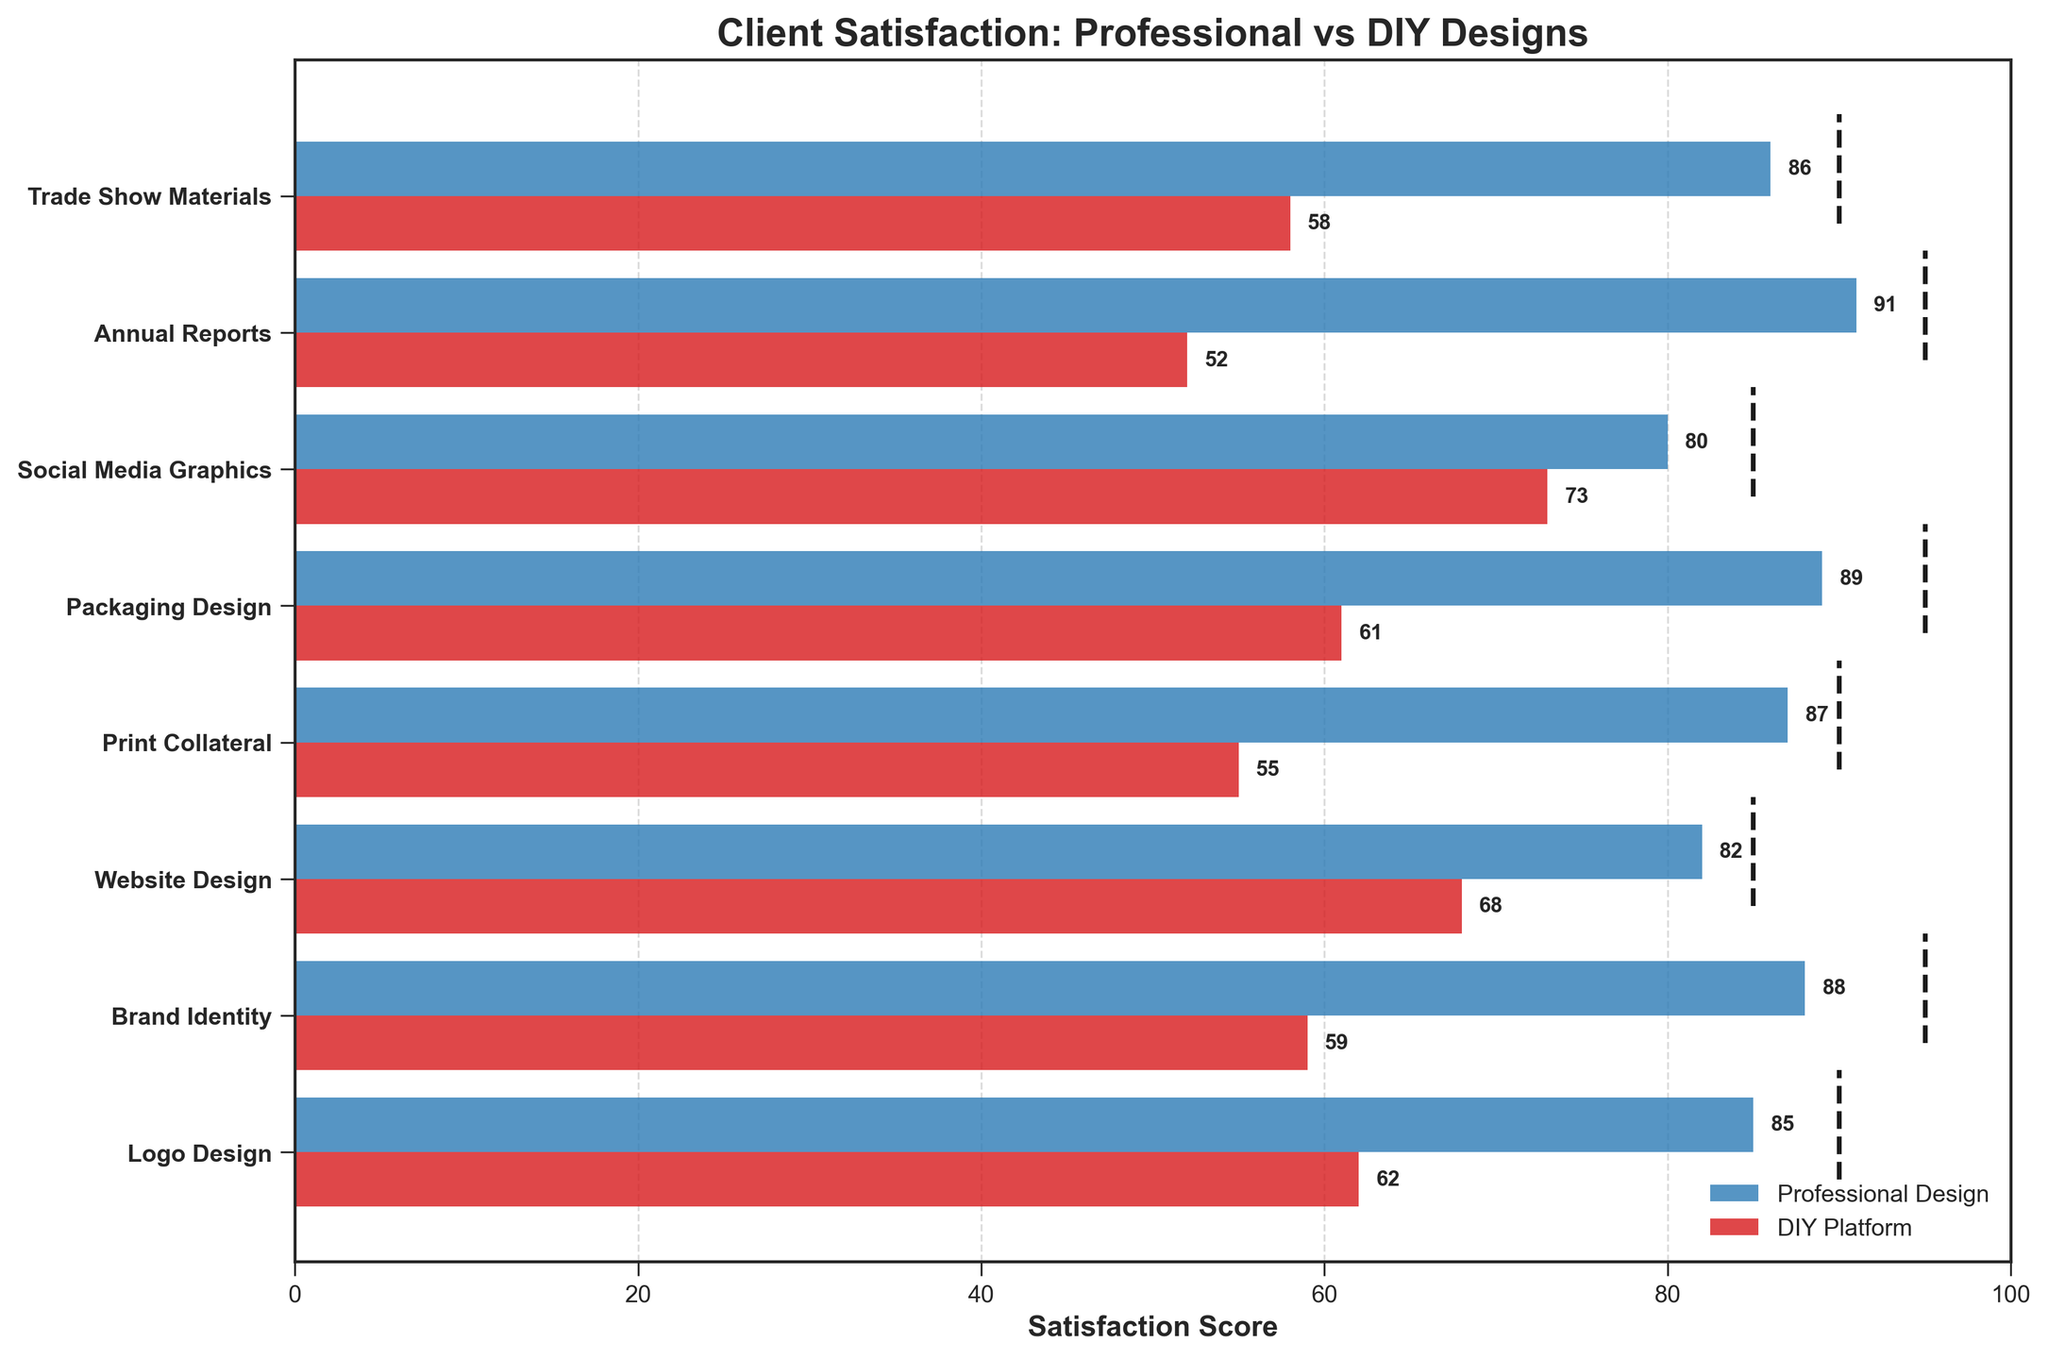What is the title of the chart? The title is usually located at the top of the chart and is clearly written. Here, it reads "Client Satisfaction: Professional vs DIY Designs"
Answer: Client Satisfaction: Professional vs DIY Designs Which category has the highest satisfaction score for Professional Design? From the chart, the highest score for Professional Design can be observed directly from the bar lengths and corresponding value labels. The highest value is 91 for Annual Reports.
Answer: Annual Reports Which category has the lowest satisfaction score for DIY Platform? We can identify the lowest satisfaction score for DIY Platform by looking at the smallest red bar and its corresponding value. The lowest is 52 for Annual Reports.
Answer: Annual Reports What is the average satisfaction score for Professional Design across all categories? To find the average, sum up all the satisfaction scores for Professional Design (85 + 88 + 82 + 87 + 89 + 80 + 91 + 86) = 688, and divide by the number of categories (8). The average is 688 / 8 = 86.
Answer: 86 Which category's satisfaction score for DIY Platform is closest to its target score? By visually comparing the red bars with the target dashed lines, the closest satisfaction score to the target can be identified. For Social Media Graphics, the satisfaction score is 73 and the target is 85, which is the smallest difference of 12.
Answer: Social Media Graphics How many categories have a Professional Design satisfaction score higher than the target score? By comparing each Professional Design score against its corresponding target score, we see that 0 categories exceed their target score since all are below or equal to the target.
Answer: 0 What is the difference in satisfaction scores between Professional Design and DIY Platform for Brand Identity? The satisfaction score for Professional Design in Brand Identity is 88, and for DIY Platform, it is 59. The difference is 88 - 59 = 29.
Answer: 29 Which category has the smallest gap between Professional Design and DIY Platform satisfaction scores? We need to calculate the differences for each category and identify the smallest one: Logo Design (85-62=23), Brand Identity (88-59=29), Website Design (82-68=14), Print Collateral (87-55=32), Packaging Design (89-61=28), Social Media Graphics (80-73=7), Annual Reports (91-52=39), Trade Show Materials (86-58=28). The smallest gap is for Social Media Graphics, which is 7.
Answer: Social Media Graphics Identify a category where the DIY Platform score exceeds its target. We compare the DIY Platform scores with their targets. None exceed their respective targets.
Answer: None What is the total difference in satisfaction scores across all categories for DIY Platform compared to their targets? Calculate the total of the differences for each category: 
(90-62) + (95-59) + (85-68) + (90-55) + (95-61) + (85-73) + (95-52) + (90-58) = 28 + 36 + 17 + 35 + 34 + 12 + 43 + 32 = 237.
Answer: 237 